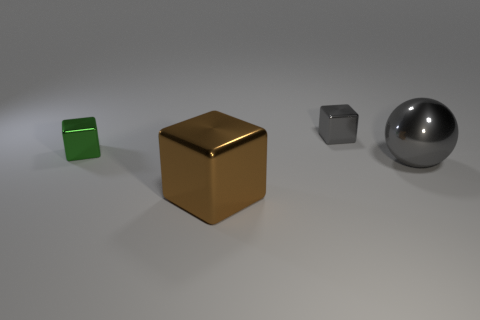Add 1 big green spheres. How many objects exist? 5 Subtract all blocks. How many objects are left? 1 Subtract all gray shiny objects. Subtract all tiny gray blocks. How many objects are left? 1 Add 2 large gray metal things. How many large gray metal things are left? 3 Add 4 small objects. How many small objects exist? 6 Subtract 0 green cylinders. How many objects are left? 4 